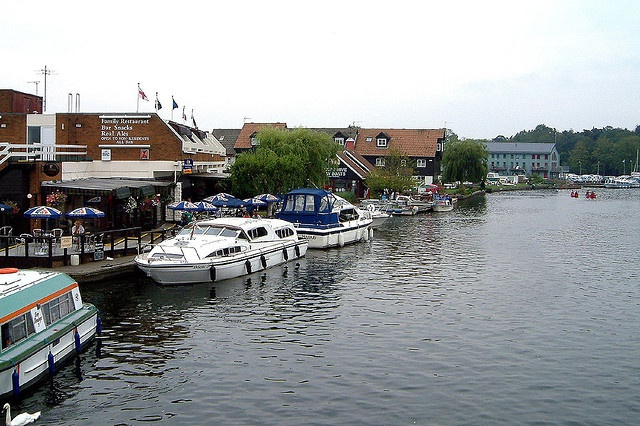Describe the objects in this image and their specific colors. I can see boat in white, darkgray, black, and gray tones, boat in white, darkgray, gray, and black tones, boat in white, black, lightgray, navy, and darkgray tones, boat in white, gray, darkgray, black, and lightgray tones, and bird in white, darkgray, black, and gray tones in this image. 